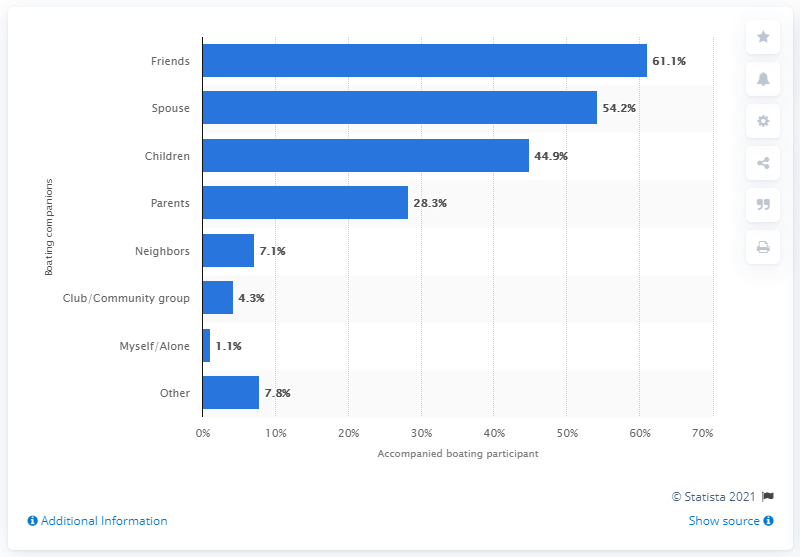Outline some significant characteristics in this image. Approximately 61.1% of boating participants were accompanied by friends at least once. 